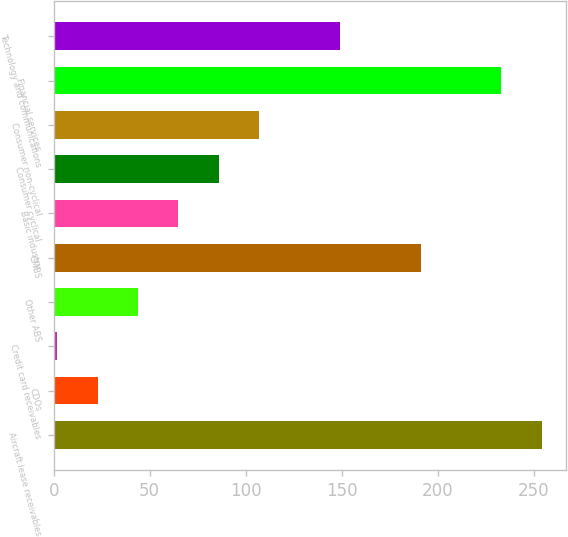Convert chart to OTSL. <chart><loc_0><loc_0><loc_500><loc_500><bar_chart><fcel>Aircraft lease receivables<fcel>CDOs<fcel>Credit card receivables<fcel>Other ABS<fcel>CMBS<fcel>Basic industry<fcel>Consumer cyclical<fcel>Consumer non-cyclical<fcel>Financial services<fcel>Technology and communications<nl><fcel>254<fcel>23<fcel>2<fcel>44<fcel>191<fcel>65<fcel>86<fcel>107<fcel>233<fcel>149<nl></chart> 